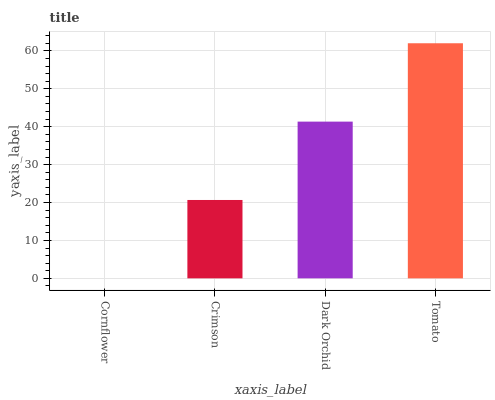Is Tomato the maximum?
Answer yes or no. Yes. Is Crimson the minimum?
Answer yes or no. No. Is Crimson the maximum?
Answer yes or no. No. Is Crimson greater than Cornflower?
Answer yes or no. Yes. Is Cornflower less than Crimson?
Answer yes or no. Yes. Is Cornflower greater than Crimson?
Answer yes or no. No. Is Crimson less than Cornflower?
Answer yes or no. No. Is Dark Orchid the high median?
Answer yes or no. Yes. Is Crimson the low median?
Answer yes or no. Yes. Is Tomato the high median?
Answer yes or no. No. Is Tomato the low median?
Answer yes or no. No. 